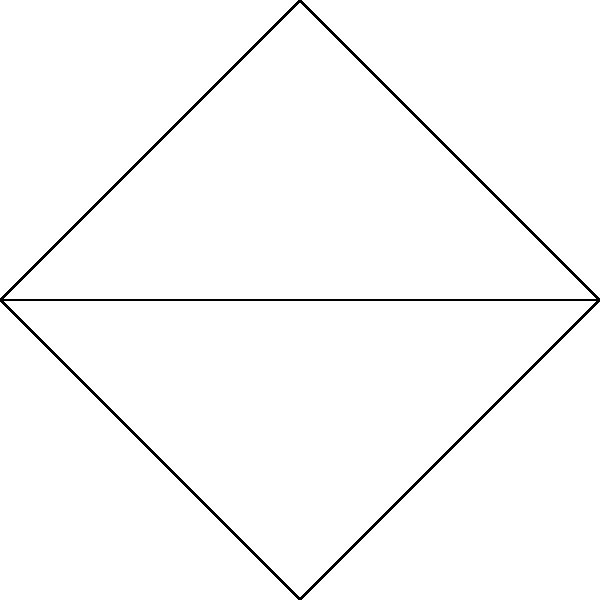As we explore the potential for collaborative research in graph theory, consider the graph shown above. How many bridges does this graph contain? Justify your answer using the properties of bridges in connected graphs. To identify bridges in this graph, let's follow these steps:

1) Recall that a bridge is an edge whose removal would disconnect the graph.

2) For each edge, we need to check if its removal would disconnect the graph:

   a) Edge $v_1v_2$: If removed, there are still paths between all vertices through $v_3$ or $v_4$.
   b) Edge $v_1v_3$: If removed, there are still paths between all vertices through $v_2$ or $v_4$.
   c) Edge $v_1v_4$: If removed, there are still paths between all vertices through $v_2$ or $v_3$.
   d) Edge $v_2v_3$: If removed, there are still paths between all vertices through $v_1$ or $v_4$.
   e) Edge $v_2v_4$: If removed, there are still paths between all vertices through $v_1$ or $v_3$.

3) We observe that for each edge, its removal does not disconnect the graph.

4) Another way to verify this is to note that every edge is part of at least one cycle in the graph. Edges that are part of a cycle cannot be bridges.

5) The cycles in this graph are:
   - $v_1v_2v_3v_1$
   - $v_1v_2v_4v_1$
   - $v_1v_3v_2v_4v_1$

Therefore, this graph contains no bridges.
Answer: 0 